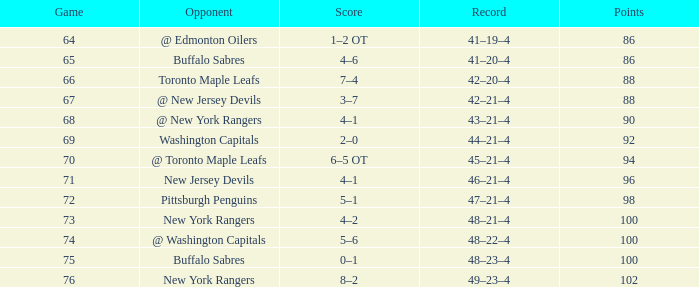Can you give me this table as a dict? {'header': ['Game', 'Opponent', 'Score', 'Record', 'Points'], 'rows': [['64', '@ Edmonton Oilers', '1–2 OT', '41–19–4', '86'], ['65', 'Buffalo Sabres', '4–6', '41–20–4', '86'], ['66', 'Toronto Maple Leafs', '7–4', '42–20–4', '88'], ['67', '@ New Jersey Devils', '3–7', '42–21–4', '88'], ['68', '@ New York Rangers', '4–1', '43–21–4', '90'], ['69', 'Washington Capitals', '2–0', '44–21–4', '92'], ['70', '@ Toronto Maple Leafs', '6–5 OT', '45–21–4', '94'], ['71', 'New Jersey Devils', '4–1', '46–21–4', '96'], ['72', 'Pittsburgh Penguins', '5–1', '47–21–4', '98'], ['73', 'New York Rangers', '4–2', '48–21–4', '100'], ['74', '@ Washington Capitals', '5–6', '48–22–4', '100'], ['75', 'Buffalo Sabres', '0–1', '48–23–4', '100'], ['76', 'New York Rangers', '8–2', '49–23–4', '102']]} Which Opponent has a Record of 45–21–4? @ Toronto Maple Leafs. 